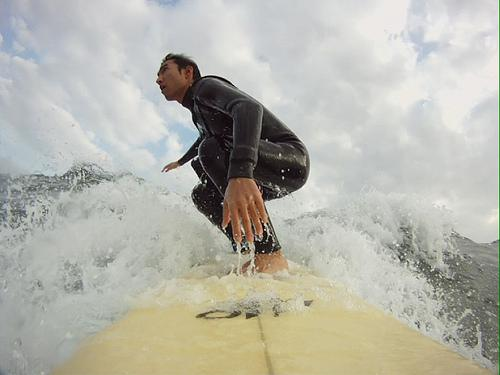Question: what is the man doing?
Choices:
A. Swimming.
B. Running.
C. Surfing.
D. Sleeping.
Answer with the letter. Answer: C Question: when was the photo taken?
Choices:
A. Sunset.
B. Sunrise.
C. At night.
D. Daytime.
Answer with the letter. Answer: D Question: why is the man squatting?
Choices:
A. To balance on the board.
B. Lifting weight.
C. Picking up the dog.
D. Trying to catch his breath.
Answer with the letter. Answer: A Question: where was the photo taken?
Choices:
A. In the ocean.
B. At the wedding.
C. On the mountain.
D. Underwater.
Answer with the letter. Answer: A Question: who is surfing?
Choices:
A. A dog.
B. The woman.
C. A man.
D. The teenagers.
Answer with the letter. Answer: C Question: how are the waves?
Choices:
A. Low.
B. There are many.
C. The surf is up.
D. They are high.
Answer with the letter. Answer: C 